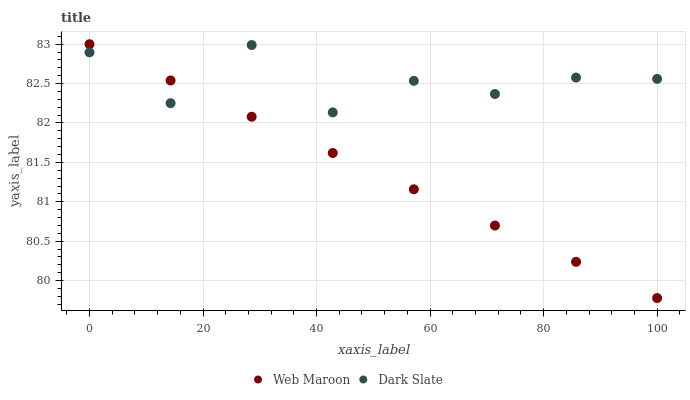Does Web Maroon have the minimum area under the curve?
Answer yes or no. Yes. Does Dark Slate have the maximum area under the curve?
Answer yes or no. Yes. Does Web Maroon have the maximum area under the curve?
Answer yes or no. No. Is Web Maroon the smoothest?
Answer yes or no. Yes. Is Dark Slate the roughest?
Answer yes or no. Yes. Is Web Maroon the roughest?
Answer yes or no. No. Does Web Maroon have the lowest value?
Answer yes or no. Yes. Does Web Maroon have the highest value?
Answer yes or no. Yes. Does Web Maroon intersect Dark Slate?
Answer yes or no. Yes. Is Web Maroon less than Dark Slate?
Answer yes or no. No. Is Web Maroon greater than Dark Slate?
Answer yes or no. No. 